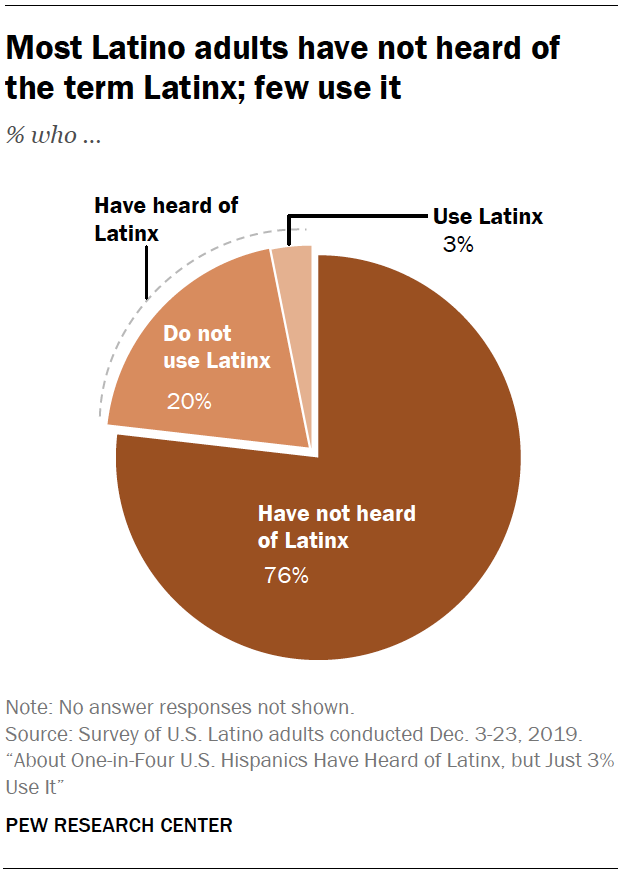What represent 76 percent in the Pie chart? In the pie chart, 76 percent represents the portion of Latino adults who have not heard of the term Latinx, according to a survey by the Pew Research Center. 